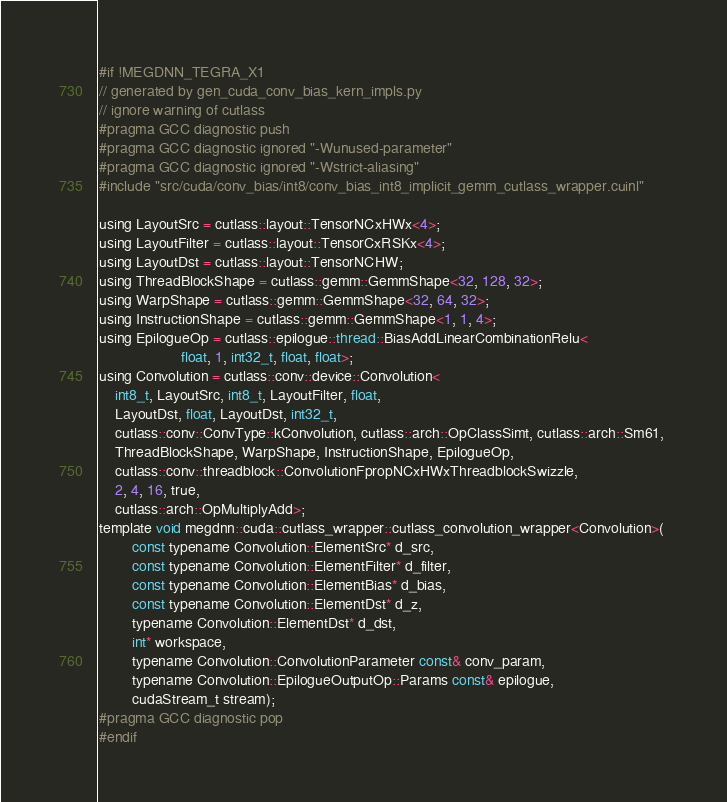<code> <loc_0><loc_0><loc_500><loc_500><_Cuda_>#if !MEGDNN_TEGRA_X1
// generated by gen_cuda_conv_bias_kern_impls.py
// ignore warning of cutlass
#pragma GCC diagnostic push
#pragma GCC diagnostic ignored "-Wunused-parameter"
#pragma GCC diagnostic ignored "-Wstrict-aliasing"
#include "src/cuda/conv_bias/int8/conv_bias_int8_implicit_gemm_cutlass_wrapper.cuinl"

using LayoutSrc = cutlass::layout::TensorNCxHWx<4>;
using LayoutFilter = cutlass::layout::TensorCxRSKx<4>;
using LayoutDst = cutlass::layout::TensorNCHW;
using ThreadBlockShape = cutlass::gemm::GemmShape<32, 128, 32>;
using WarpShape = cutlass::gemm::GemmShape<32, 64, 32>;
using InstructionShape = cutlass::gemm::GemmShape<1, 1, 4>;
using EpilogueOp = cutlass::epilogue::thread::BiasAddLinearCombinationRelu<
                    float, 1, int32_t, float, float>;
using Convolution = cutlass::conv::device::Convolution<
    int8_t, LayoutSrc, int8_t, LayoutFilter, float, 
    LayoutDst, float, LayoutDst, int32_t, 
    cutlass::conv::ConvType::kConvolution, cutlass::arch::OpClassSimt, cutlass::arch::Sm61, 
    ThreadBlockShape, WarpShape, InstructionShape, EpilogueOp, 
    cutlass::conv::threadblock::ConvolutionFpropNCxHWxThreadblockSwizzle, 
    2, 4, 16, true, 
    cutlass::arch::OpMultiplyAdd>;
template void megdnn::cuda::cutlass_wrapper::cutlass_convolution_wrapper<Convolution>(
        const typename Convolution::ElementSrc* d_src, 
        const typename Convolution::ElementFilter* d_filter, 
        const typename Convolution::ElementBias* d_bias, 
        const typename Convolution::ElementDst* d_z, 
        typename Convolution::ElementDst* d_dst, 
        int* workspace, 
        typename Convolution::ConvolutionParameter const& conv_param, 
        typename Convolution::EpilogueOutputOp::Params const& epilogue, 
        cudaStream_t stream);
#pragma GCC diagnostic pop
#endif
</code> 